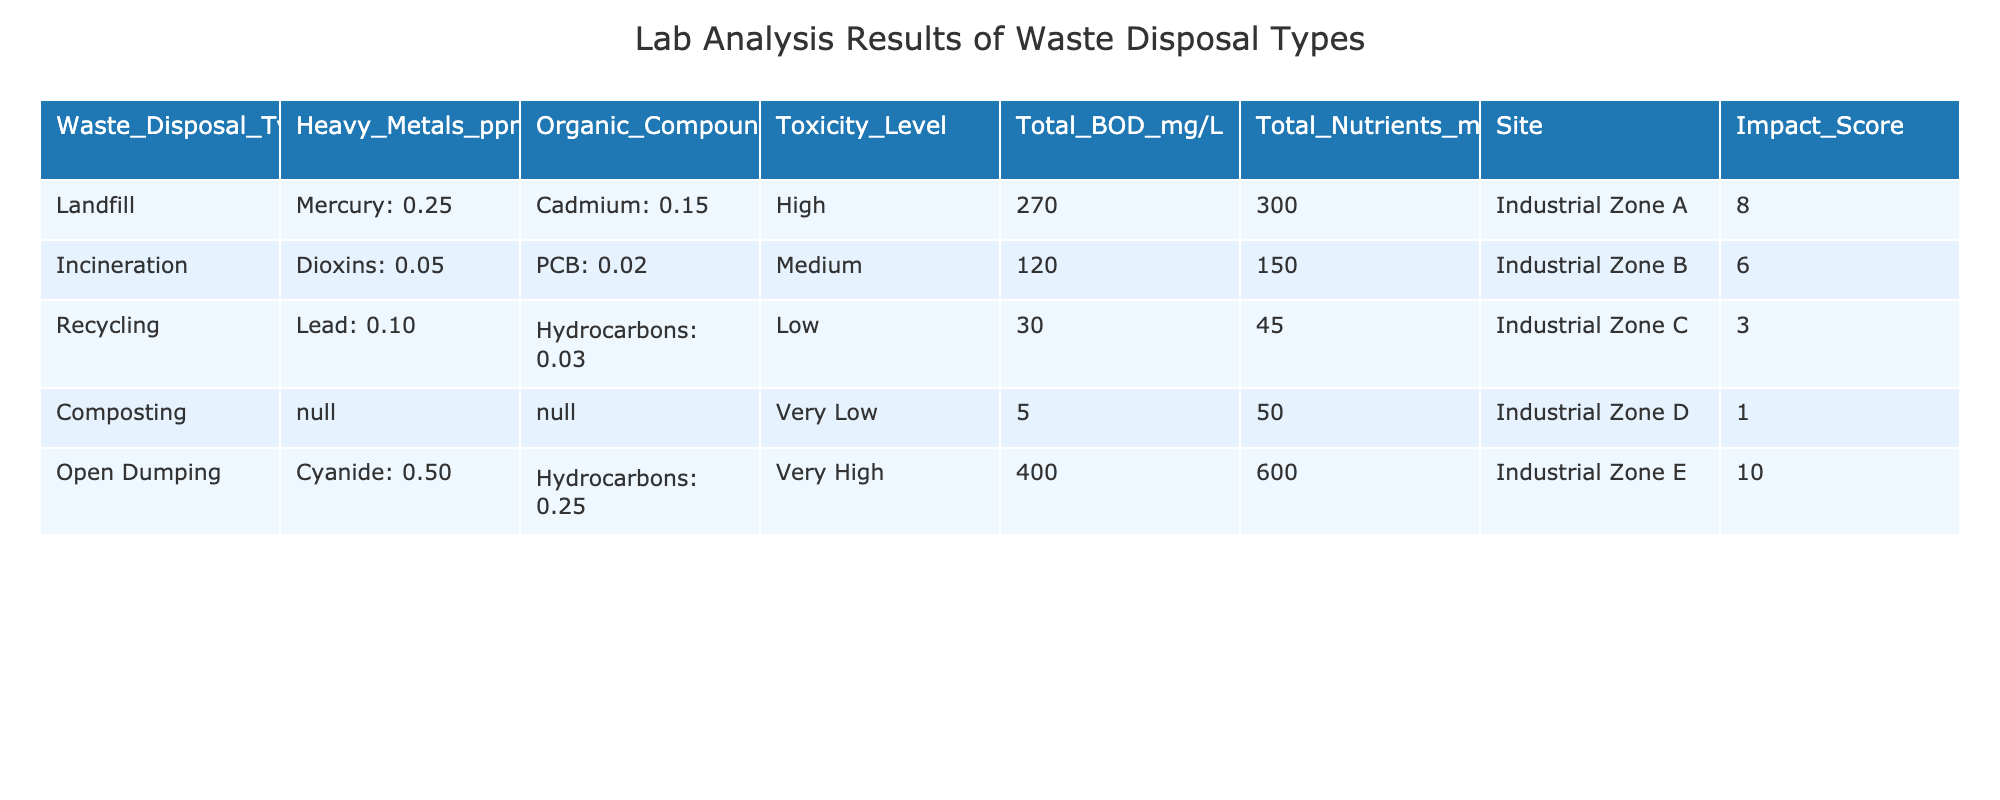What is the impact score for open dumping? The impact score for open dumping is listed in the table as 10.
Answer: 10 What type of waste disposal has the highest total BOD? By examining the total BOD column, open dumping has the highest total BOD at 400 mg/L.
Answer: 400 mg/L Is the toxicity level of landfill waste high? The toxicity level for landfill waste is categorized as high, according to the table.
Answer: Yes What is the difference in total nutrients between landfill and recycling? The total nutrients for landfill is 300 mg/L, and for recycling, it is 45 mg/L. The difference is 300 - 45 = 255 mg/L.
Answer: 255 mg/L Which waste disposal type has the lowest impact score and what is the reason? Composting has the lowest impact score of 1, indicated by the very low toxicity level and minimal heavy metal and organic compounds presence in the table.
Answer: Composting, impact score 1 due to very low toxicity Which site generates the highest level of heavy metals, and which heavy metal is it? Open dumping generates the highest level of heavy metals with cyanide present at 0.50 ppm.
Answer: Open dumping, cyanide 0.50 ppm What is the total BOD for recycling and composting combined? The total BOD for recycling is 30 mg/L and for composting is 5 mg/L. Adding these together gives 30 + 5 = 35 mg/L.
Answer: 35 mg/L How does the toxicity level of incineration compare to that of landfill? Incineration has a medium toxicity level while landfill has a high toxicity level, indicating that landfill is more toxic compared to incineration.
Answer: Landfill is more toxic than incineration What is the average heavy metal level for landfill and open dumping? Landfill has mercury at 0.25 ppm and open dumping has cyanide at 0.50 ppm. The average is (0.25 + 0.50) / 2 = 0.375 ppm.
Answer: 0.375 ppm 